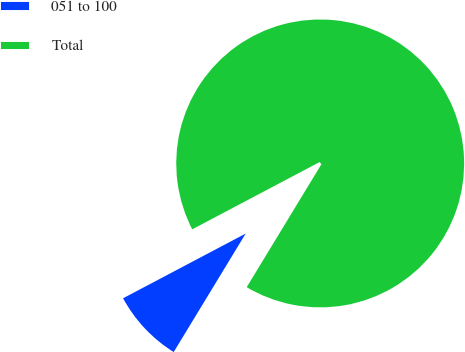Convert chart to OTSL. <chart><loc_0><loc_0><loc_500><loc_500><pie_chart><fcel>051 to 100<fcel>Total<nl><fcel>8.58%<fcel>91.42%<nl></chart> 